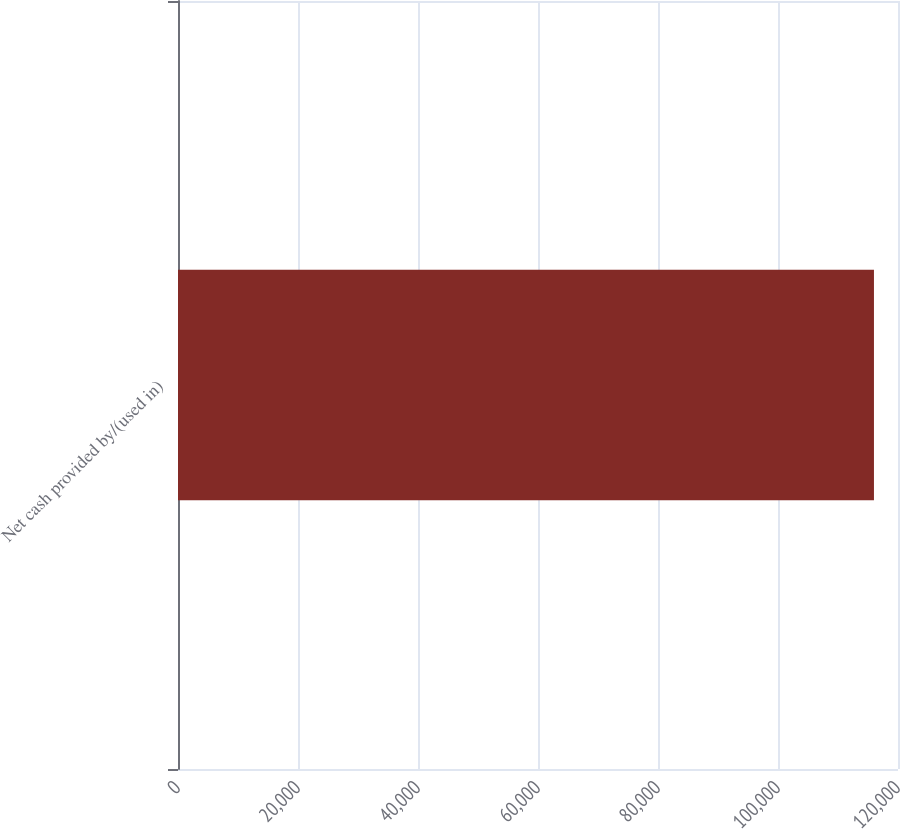<chart> <loc_0><loc_0><loc_500><loc_500><bar_chart><fcel>Net cash provided by/(used in)<nl><fcel>115993<nl></chart> 